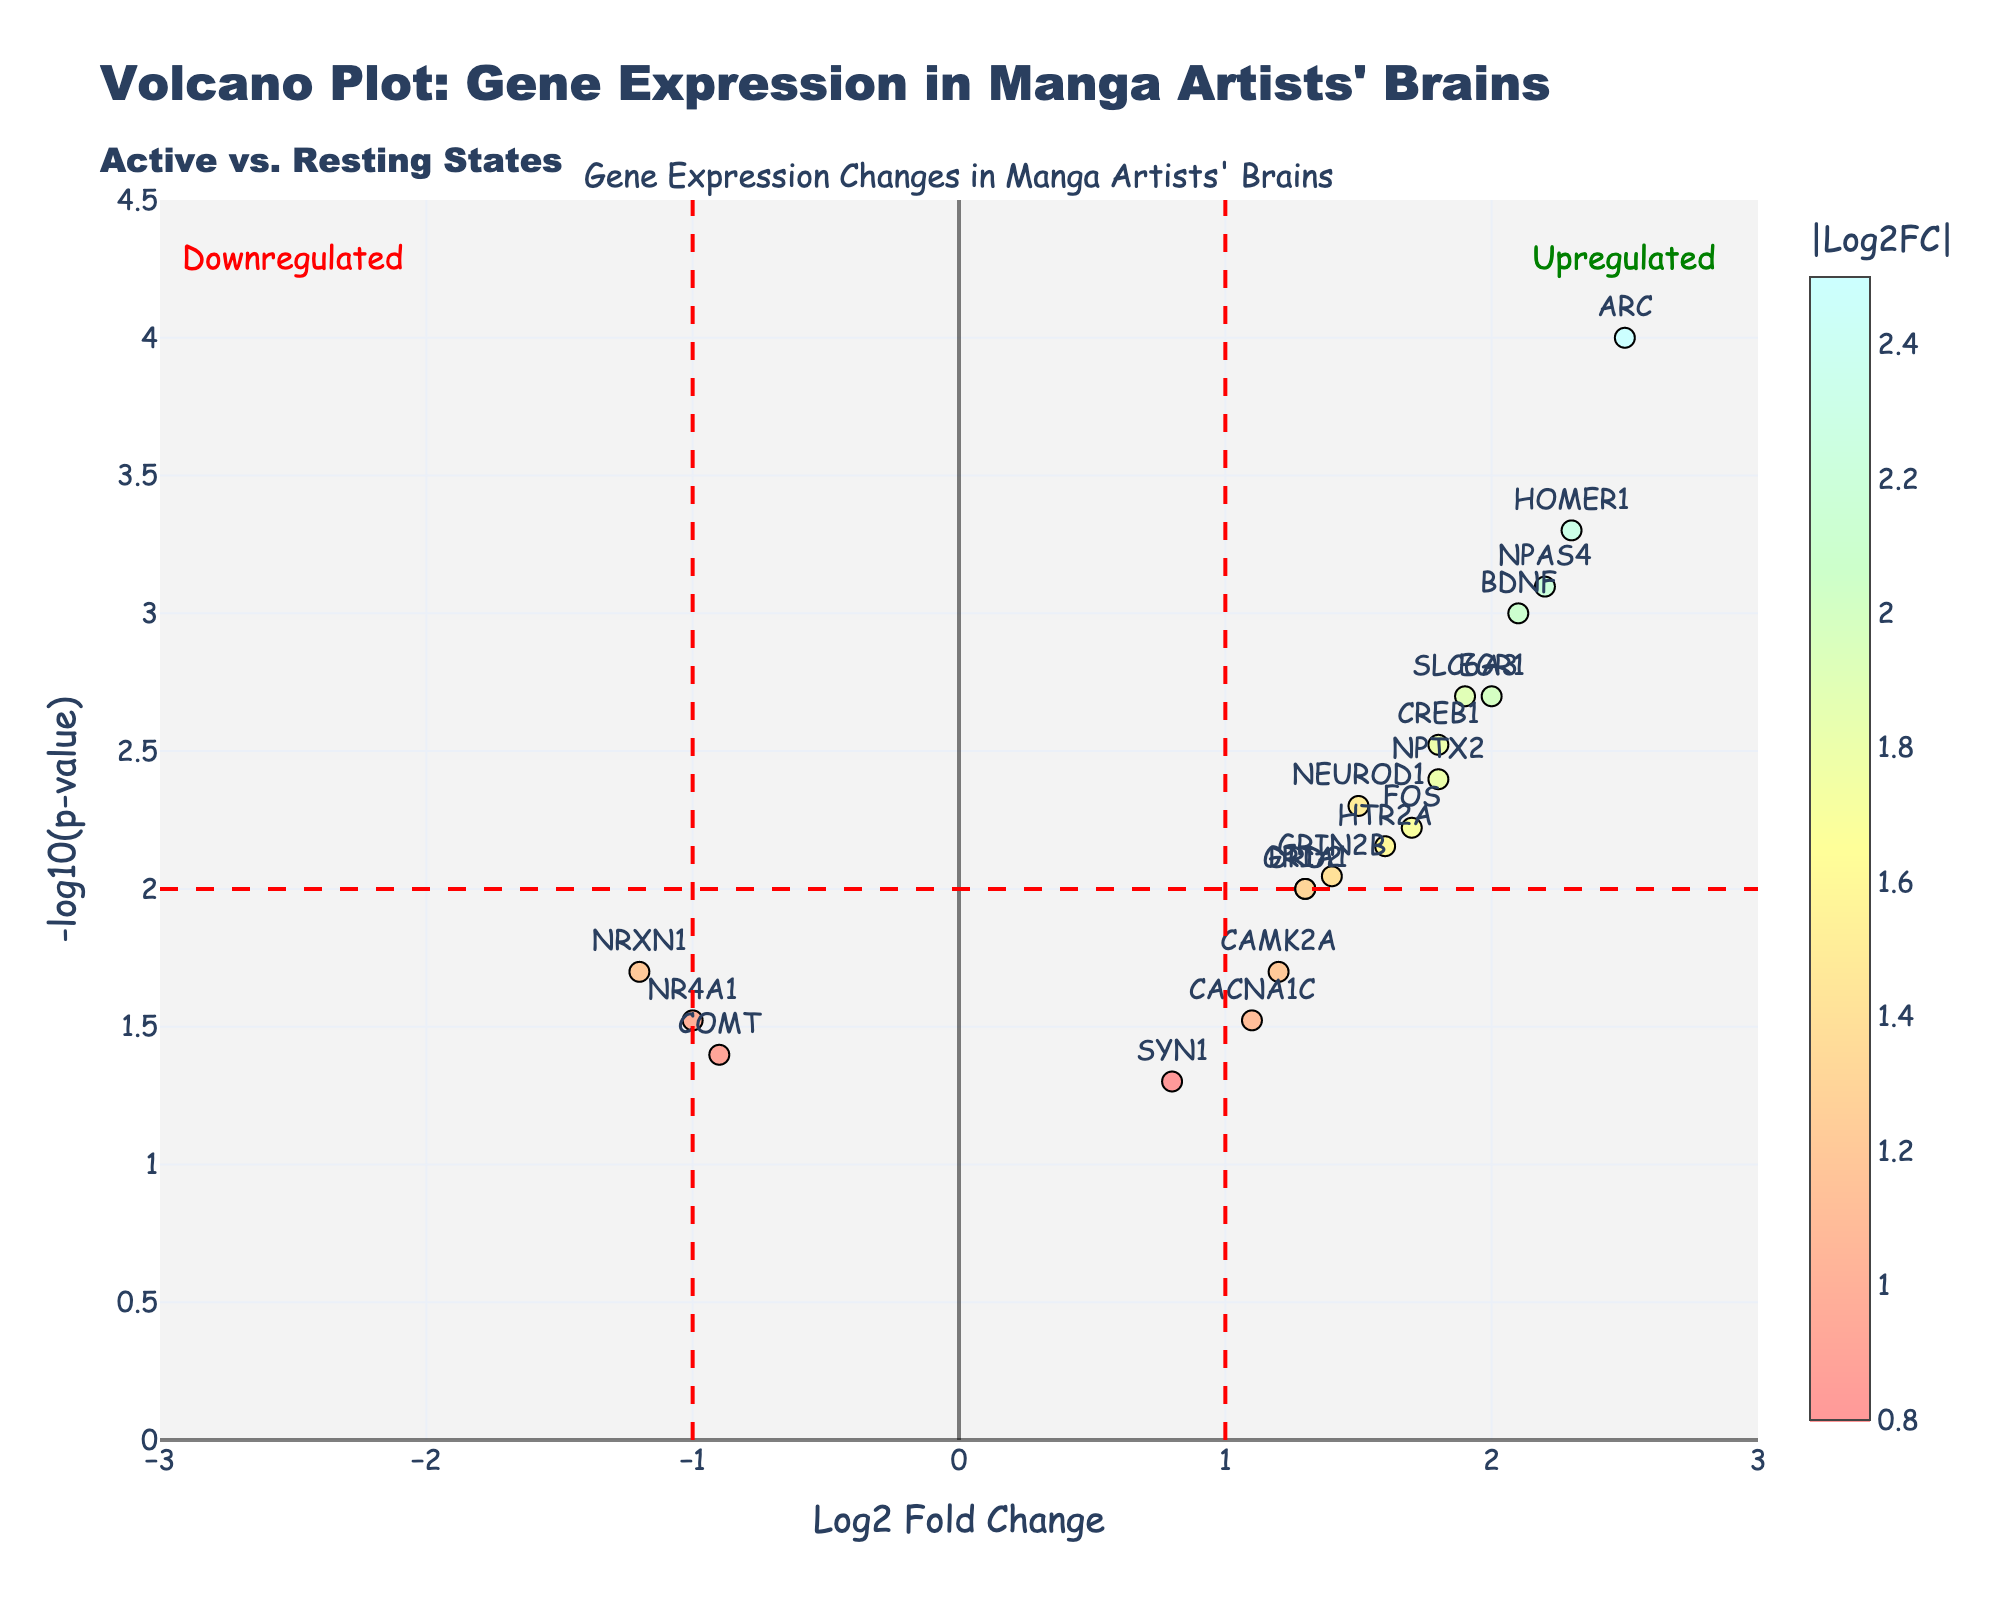What is the title of the figure? Look at the top of the figure where the title is located.
Answer: Volcano Plot: Gene Expression in Manga Artists' Brains How many genes are significantly upregulated (Log2 Fold Change > 1 and -log10(p-value) > 2)? Identify points with Log2 Fold Change > 1 and -log10(p-value) > 2. Count these points.
Answer: 4 Which gene has the highest Log2 Fold Change? Look for the gene with the highest x-axis value on the plot.
Answer: ARC What is the range of the x-axis? Check the x-axis range indicated in the figure's axis properties.
Answer: -3 to 3 Which gene has the lowest p-value? The y-axis represents -log10(p-value), so the gene with the highest y-axis value has the lowest p-value. Identify the highest point on the y-axis.
Answer: ARC What is the color of the data points with the highest absolute Log2 Fold Change? Refer to the color scale bar to identify the color representing the highest values.
Answer: Dark red How many genes have a Log2 Fold Change between -1 and 1? Count the number of points between Log2 Fold Change -1 and 1 on the x-axis.
Answer: 4 Which gene is more significantly upregulated: BDNF or CREB1? Compare the -log10(p-value) values of BDNF and CREB1. The gene with the higher -log10(p-value) is more significantly upregulated.
Answer: BDNF Are there any genes with a negative Log2 Fold Change? If so, how many? Look for data points with negative Log2 Fold Changes and count them.
Answer: 3 What do the red lines at Log2 Fold Change = ±1 and -log10(p-value) = 2 represent? The red lines are thresholds for significant Log2 Fold Change (±1) and p-value (0.01).
Answer: Significance thresholds 